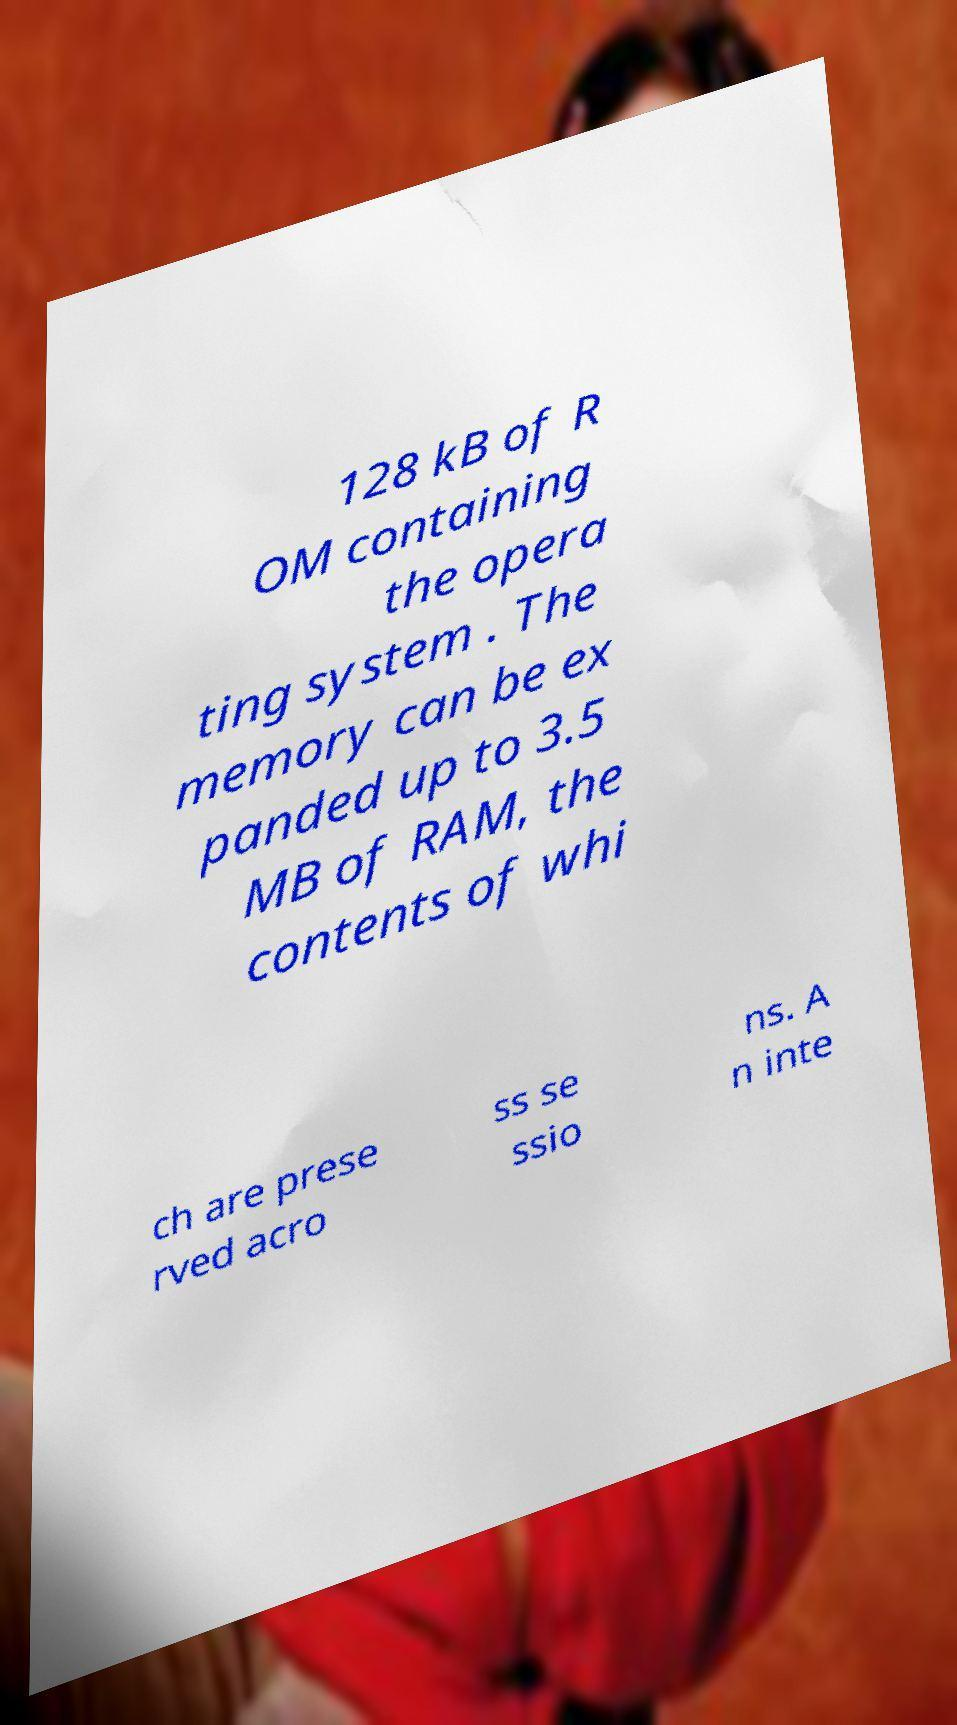Could you extract and type out the text from this image? 128 kB of R OM containing the opera ting system . The memory can be ex panded up to 3.5 MB of RAM, the contents of whi ch are prese rved acro ss se ssio ns. A n inte 